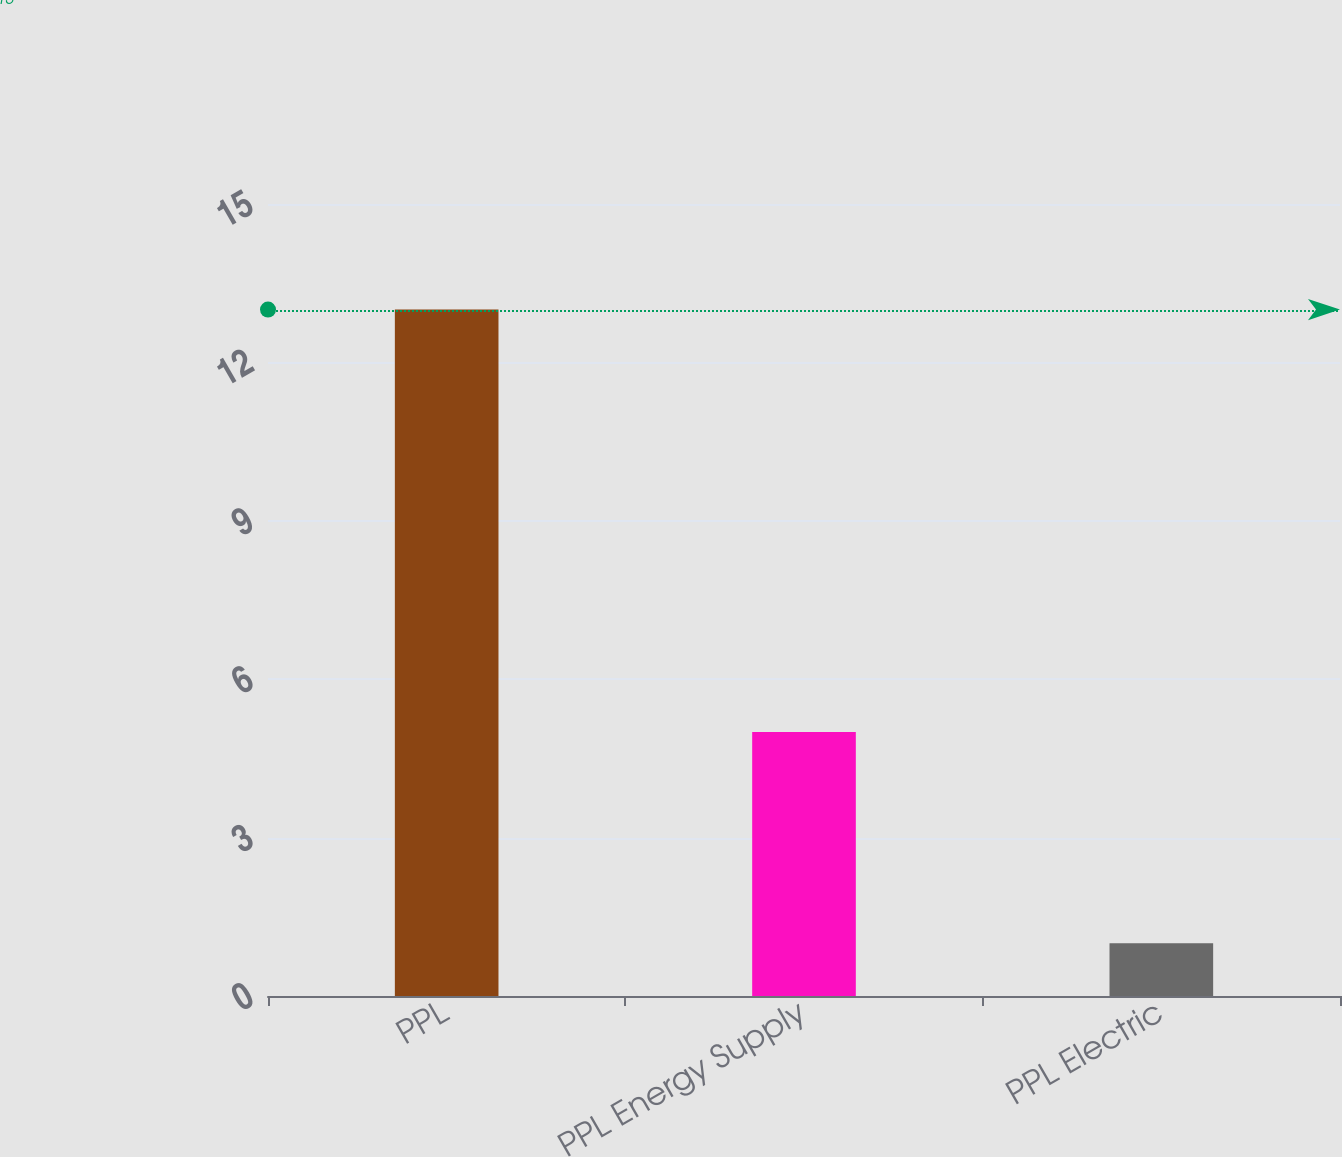Convert chart. <chart><loc_0><loc_0><loc_500><loc_500><bar_chart><fcel>PPL<fcel>PPL Energy Supply<fcel>PPL Electric<nl><fcel>13<fcel>5<fcel>1<nl></chart> 